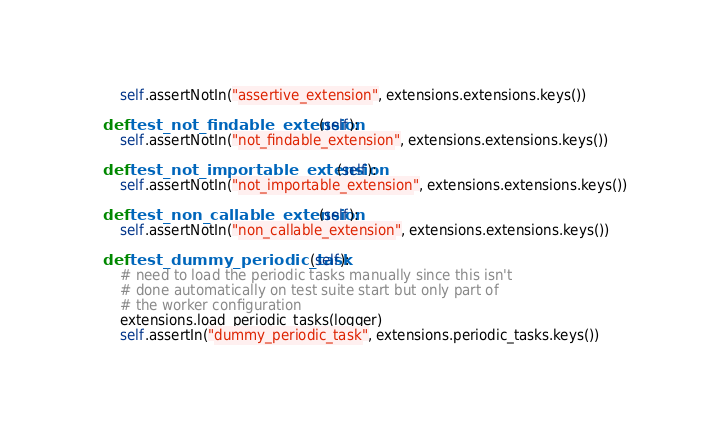<code> <loc_0><loc_0><loc_500><loc_500><_Python_>        self.assertNotIn("assertive_extension", extensions.extensions.keys())

    def test_not_findable_extension(self):
        self.assertNotIn("not_findable_extension", extensions.extensions.keys())

    def test_not_importable_extension(self):
        self.assertNotIn("not_importable_extension", extensions.extensions.keys())

    def test_non_callable_extension(self):
        self.assertNotIn("non_callable_extension", extensions.extensions.keys())

    def test_dummy_periodic_task(self):
        # need to load the periodic tasks manually since this isn't
        # done automatically on test suite start but only part of
        # the worker configuration
        extensions.load_periodic_tasks(logger)
        self.assertIn("dummy_periodic_task", extensions.periodic_tasks.keys())
</code> 